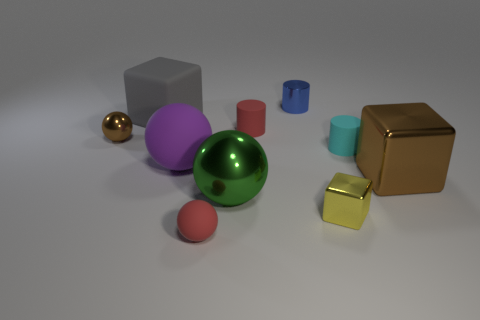Subtract all tiny red balls. How many balls are left? 3 Subtract all gray spheres. Subtract all purple cylinders. How many spheres are left? 4 Subtract all balls. How many objects are left? 6 Add 6 big metallic cubes. How many big metallic cubes are left? 7 Add 1 tiny blue cylinders. How many tiny blue cylinders exist? 2 Subtract 0 green cylinders. How many objects are left? 10 Subtract all tiny blue objects. Subtract all tiny blue things. How many objects are left? 8 